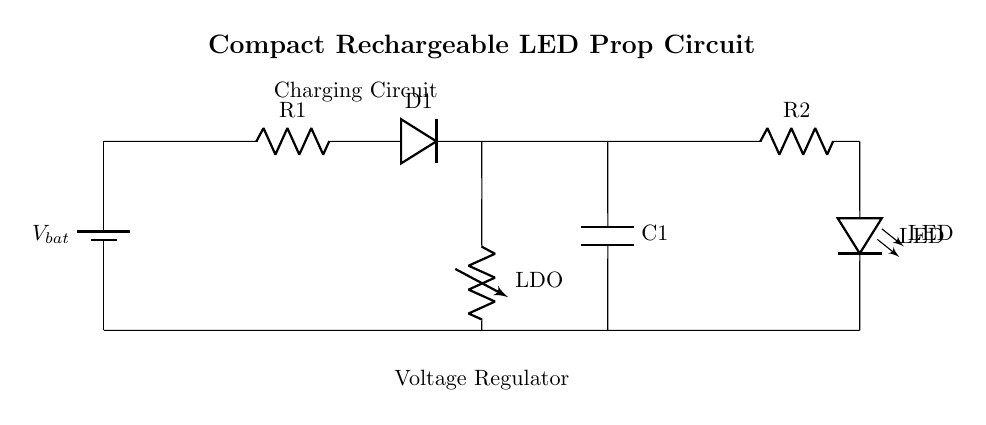What type of battery is used in the circuit? The circuit diagram shows a standard battery symbol labeled as V_bat, indicating a rechargeable battery, which is appropriate for powering the circuit.
Answer: rechargeable battery What component is used for voltage regulation? The circuit features an LDO (Low Dropout Regulator) symbolized in the diagram, which regulates the output voltage from the battery to the proper level for the LEDs.
Answer: LDO What is the purpose of the resistor R1 in the charging circuit? Resistor R1 is used to limit the current flowing from the battery to the rest of the circuit during the charging phase, protecting components from excessive current.
Answer: current limiting How many LEDs are connected in this circuit? The diagram indicates that there is one LED connected in the circuit, labeled as LED and located at the bottom right section of the circuit.
Answer: one What happens to the voltage across the capacitor C1? Capacitor C1 smooths the voltage after rectification by storing and releasing electrical energy as needed, which helps maintain a steady voltage supply to the connected components.
Answer: voltage smoothing What is the relationship between the resistor R2 and the LED? Resistor R2 is placed in series with the LED to limit the current that flows through the LED, preventing it from drawing too much current and potentially damaging itself.
Answer: current limitation 